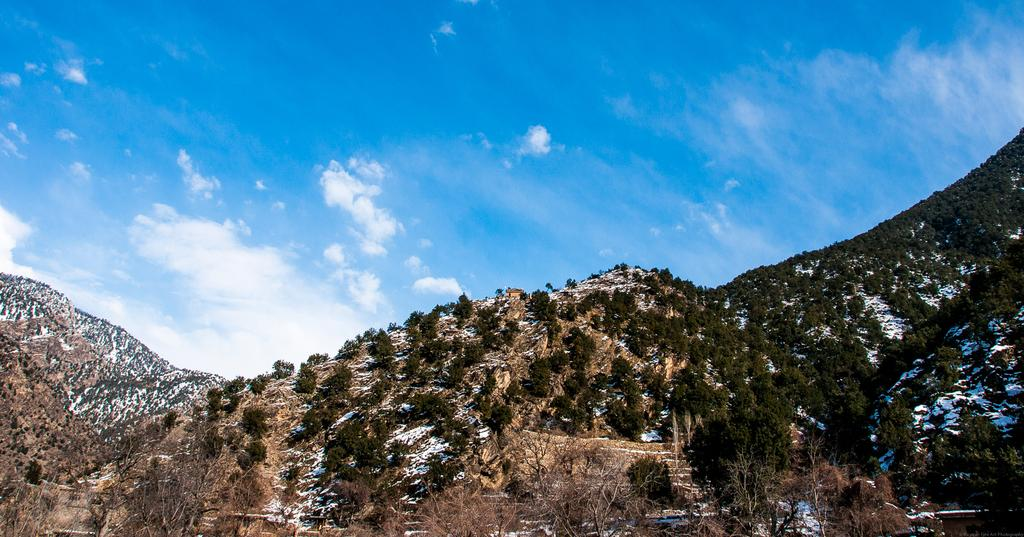What type of vegetation can be seen in the image? There are trees in the image. What type of terrain is visible in the image? There are hills in the image. What is the weather like in the image? There is snow in the image, indicating a cold or wintery environment. What is visible in the background of the image? The sky is visible in the background of the image. Can you see any waves in the image? There are no waves present in the image; it features trees, hills, snow, and a sky. Are there any wrens visible in the image? There are no wrens present in the image. 